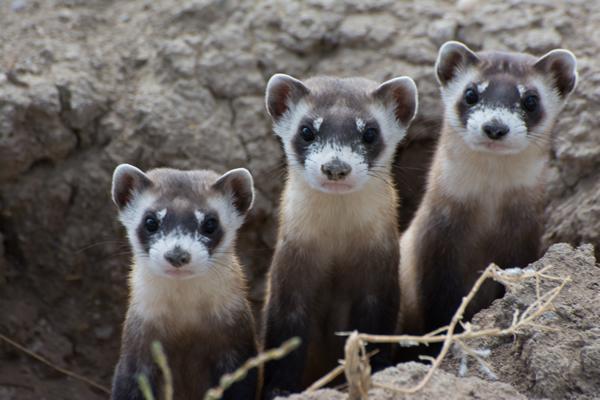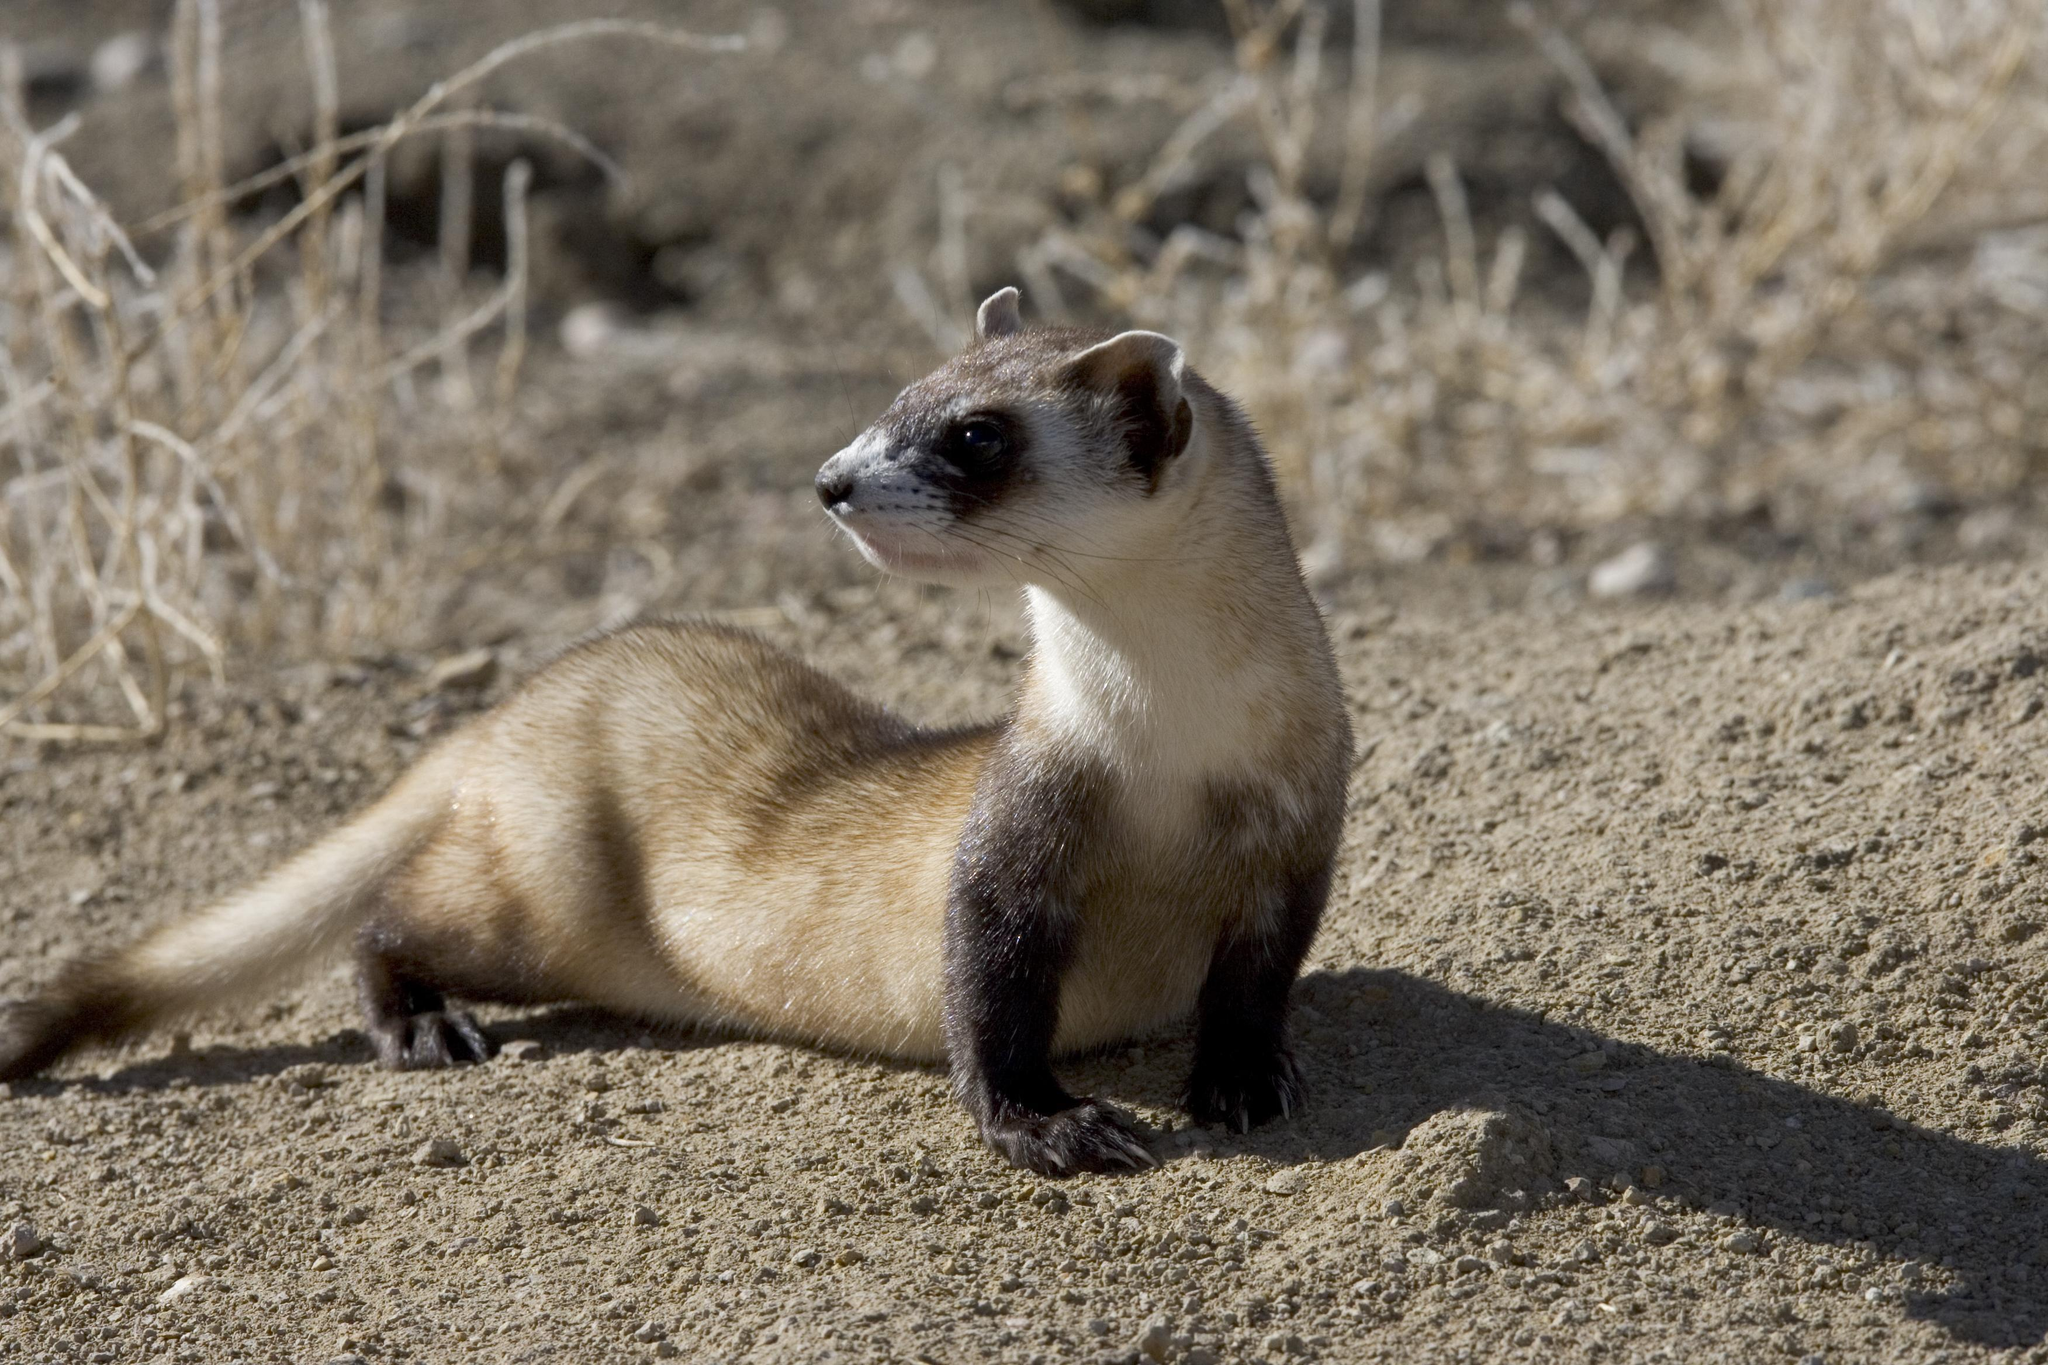The first image is the image on the left, the second image is the image on the right. Assess this claim about the two images: "There are four ferrets". Correct or not? Answer yes or no. Yes. The first image is the image on the left, the second image is the image on the right. Assess this claim about the two images: "there are exactly three animals in one of the images". Correct or not? Answer yes or no. Yes. The first image is the image on the left, the second image is the image on the right. Given the left and right images, does the statement "There are no more than 3 ferrets shown." hold true? Answer yes or no. No. The first image is the image on the left, the second image is the image on the right. Evaluate the accuracy of this statement regarding the images: "An image shows three ferrets, which are looking forward with heads up.". Is it true? Answer yes or no. Yes. 